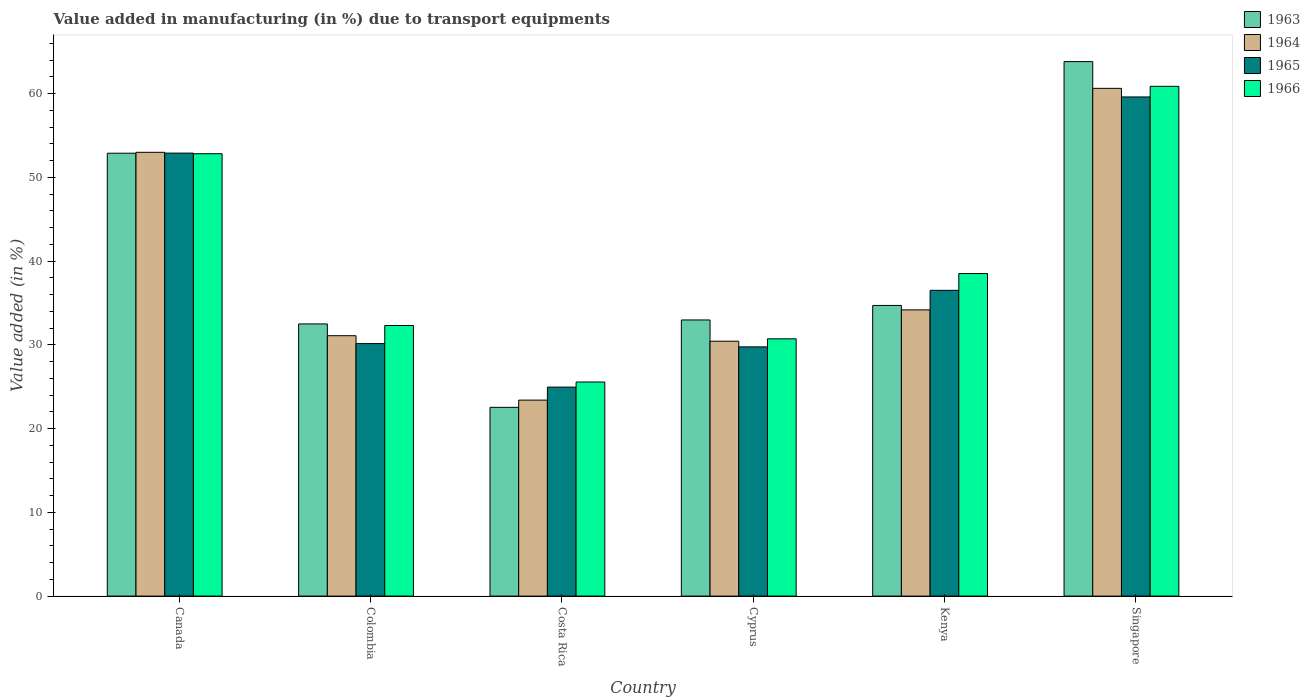How many groups of bars are there?
Offer a terse response. 6. Are the number of bars per tick equal to the number of legend labels?
Your answer should be compact. Yes. Are the number of bars on each tick of the X-axis equal?
Offer a terse response. Yes. How many bars are there on the 3rd tick from the right?
Offer a very short reply. 4. What is the label of the 3rd group of bars from the left?
Provide a short and direct response. Costa Rica. In how many cases, is the number of bars for a given country not equal to the number of legend labels?
Provide a succinct answer. 0. What is the percentage of value added in manufacturing due to transport equipments in 1965 in Singapore?
Ensure brevity in your answer.  59.59. Across all countries, what is the maximum percentage of value added in manufacturing due to transport equipments in 1963?
Offer a very short reply. 63.81. Across all countries, what is the minimum percentage of value added in manufacturing due to transport equipments in 1966?
Provide a short and direct response. 25.56. In which country was the percentage of value added in manufacturing due to transport equipments in 1966 maximum?
Make the answer very short. Singapore. What is the total percentage of value added in manufacturing due to transport equipments in 1965 in the graph?
Your response must be concise. 233.83. What is the difference between the percentage of value added in manufacturing due to transport equipments in 1964 in Colombia and that in Kenya?
Ensure brevity in your answer.  -3.08. What is the difference between the percentage of value added in manufacturing due to transport equipments in 1963 in Singapore and the percentage of value added in manufacturing due to transport equipments in 1965 in Costa Rica?
Your answer should be compact. 38.86. What is the average percentage of value added in manufacturing due to transport equipments in 1963 per country?
Your answer should be very brief. 39.9. What is the difference between the percentage of value added in manufacturing due to transport equipments of/in 1965 and percentage of value added in manufacturing due to transport equipments of/in 1964 in Canada?
Offer a terse response. -0.1. In how many countries, is the percentage of value added in manufacturing due to transport equipments in 1966 greater than 16 %?
Ensure brevity in your answer.  6. What is the ratio of the percentage of value added in manufacturing due to transport equipments in 1963 in Canada to that in Cyprus?
Provide a succinct answer. 1.6. Is the percentage of value added in manufacturing due to transport equipments in 1964 in Canada less than that in Cyprus?
Offer a very short reply. No. What is the difference between the highest and the second highest percentage of value added in manufacturing due to transport equipments in 1964?
Ensure brevity in your answer.  -26.45. What is the difference between the highest and the lowest percentage of value added in manufacturing due to transport equipments in 1966?
Your answer should be very brief. 35.3. In how many countries, is the percentage of value added in manufacturing due to transport equipments in 1964 greater than the average percentage of value added in manufacturing due to transport equipments in 1964 taken over all countries?
Ensure brevity in your answer.  2. What does the 3rd bar from the left in Colombia represents?
Give a very brief answer. 1965. What does the 2nd bar from the right in Canada represents?
Ensure brevity in your answer.  1965. Is it the case that in every country, the sum of the percentage of value added in manufacturing due to transport equipments in 1963 and percentage of value added in manufacturing due to transport equipments in 1966 is greater than the percentage of value added in manufacturing due to transport equipments in 1965?
Your answer should be compact. Yes. Are all the bars in the graph horizontal?
Make the answer very short. No. What is the difference between two consecutive major ticks on the Y-axis?
Make the answer very short. 10. Does the graph contain any zero values?
Your answer should be compact. No. Does the graph contain grids?
Make the answer very short. No. Where does the legend appear in the graph?
Offer a very short reply. Top right. What is the title of the graph?
Provide a short and direct response. Value added in manufacturing (in %) due to transport equipments. What is the label or title of the X-axis?
Provide a short and direct response. Country. What is the label or title of the Y-axis?
Your answer should be very brief. Value added (in %). What is the Value added (in %) of 1963 in Canada?
Offer a very short reply. 52.87. What is the Value added (in %) of 1964 in Canada?
Offer a terse response. 52.98. What is the Value added (in %) of 1965 in Canada?
Provide a succinct answer. 52.89. What is the Value added (in %) of 1966 in Canada?
Your answer should be very brief. 52.81. What is the Value added (in %) in 1963 in Colombia?
Make the answer very short. 32.49. What is the Value added (in %) of 1964 in Colombia?
Offer a very short reply. 31.09. What is the Value added (in %) of 1965 in Colombia?
Make the answer very short. 30.15. What is the Value added (in %) of 1966 in Colombia?
Your answer should be compact. 32.3. What is the Value added (in %) in 1963 in Costa Rica?
Keep it short and to the point. 22.53. What is the Value added (in %) in 1964 in Costa Rica?
Ensure brevity in your answer.  23.4. What is the Value added (in %) in 1965 in Costa Rica?
Keep it short and to the point. 24.95. What is the Value added (in %) of 1966 in Costa Rica?
Your answer should be very brief. 25.56. What is the Value added (in %) of 1963 in Cyprus?
Offer a terse response. 32.97. What is the Value added (in %) of 1964 in Cyprus?
Your answer should be compact. 30.43. What is the Value added (in %) in 1965 in Cyprus?
Make the answer very short. 29.75. What is the Value added (in %) of 1966 in Cyprus?
Offer a very short reply. 30.72. What is the Value added (in %) in 1963 in Kenya?
Provide a short and direct response. 34.7. What is the Value added (in %) in 1964 in Kenya?
Your answer should be compact. 34.17. What is the Value added (in %) of 1965 in Kenya?
Give a very brief answer. 36.5. What is the Value added (in %) of 1966 in Kenya?
Offer a very short reply. 38.51. What is the Value added (in %) of 1963 in Singapore?
Keep it short and to the point. 63.81. What is the Value added (in %) of 1964 in Singapore?
Your response must be concise. 60.62. What is the Value added (in %) in 1965 in Singapore?
Your answer should be very brief. 59.59. What is the Value added (in %) in 1966 in Singapore?
Keep it short and to the point. 60.86. Across all countries, what is the maximum Value added (in %) of 1963?
Keep it short and to the point. 63.81. Across all countries, what is the maximum Value added (in %) of 1964?
Provide a short and direct response. 60.62. Across all countries, what is the maximum Value added (in %) of 1965?
Make the answer very short. 59.59. Across all countries, what is the maximum Value added (in %) of 1966?
Give a very brief answer. 60.86. Across all countries, what is the minimum Value added (in %) of 1963?
Make the answer very short. 22.53. Across all countries, what is the minimum Value added (in %) in 1964?
Provide a succinct answer. 23.4. Across all countries, what is the minimum Value added (in %) in 1965?
Your answer should be very brief. 24.95. Across all countries, what is the minimum Value added (in %) in 1966?
Provide a succinct answer. 25.56. What is the total Value added (in %) of 1963 in the graph?
Give a very brief answer. 239.38. What is the total Value added (in %) in 1964 in the graph?
Provide a short and direct response. 232.68. What is the total Value added (in %) of 1965 in the graph?
Provide a succinct answer. 233.83. What is the total Value added (in %) of 1966 in the graph?
Ensure brevity in your answer.  240.76. What is the difference between the Value added (in %) of 1963 in Canada and that in Colombia?
Your answer should be compact. 20.38. What is the difference between the Value added (in %) of 1964 in Canada and that in Colombia?
Make the answer very short. 21.9. What is the difference between the Value added (in %) of 1965 in Canada and that in Colombia?
Keep it short and to the point. 22.74. What is the difference between the Value added (in %) of 1966 in Canada and that in Colombia?
Keep it short and to the point. 20.51. What is the difference between the Value added (in %) in 1963 in Canada and that in Costa Rica?
Provide a short and direct response. 30.34. What is the difference between the Value added (in %) in 1964 in Canada and that in Costa Rica?
Ensure brevity in your answer.  29.59. What is the difference between the Value added (in %) of 1965 in Canada and that in Costa Rica?
Give a very brief answer. 27.93. What is the difference between the Value added (in %) of 1966 in Canada and that in Costa Rica?
Provide a succinct answer. 27.25. What is the difference between the Value added (in %) in 1963 in Canada and that in Cyprus?
Provide a succinct answer. 19.91. What is the difference between the Value added (in %) in 1964 in Canada and that in Cyprus?
Offer a terse response. 22.55. What is the difference between the Value added (in %) of 1965 in Canada and that in Cyprus?
Your answer should be very brief. 23.13. What is the difference between the Value added (in %) in 1966 in Canada and that in Cyprus?
Offer a very short reply. 22.1. What is the difference between the Value added (in %) in 1963 in Canada and that in Kenya?
Your answer should be very brief. 18.17. What is the difference between the Value added (in %) in 1964 in Canada and that in Kenya?
Offer a very short reply. 18.81. What is the difference between the Value added (in %) of 1965 in Canada and that in Kenya?
Ensure brevity in your answer.  16.38. What is the difference between the Value added (in %) in 1966 in Canada and that in Kenya?
Your response must be concise. 14.3. What is the difference between the Value added (in %) in 1963 in Canada and that in Singapore?
Your response must be concise. -10.94. What is the difference between the Value added (in %) in 1964 in Canada and that in Singapore?
Offer a terse response. -7.63. What is the difference between the Value added (in %) of 1965 in Canada and that in Singapore?
Provide a succinct answer. -6.71. What is the difference between the Value added (in %) of 1966 in Canada and that in Singapore?
Your answer should be compact. -8.05. What is the difference between the Value added (in %) in 1963 in Colombia and that in Costa Rica?
Your answer should be very brief. 9.96. What is the difference between the Value added (in %) of 1964 in Colombia and that in Costa Rica?
Provide a short and direct response. 7.69. What is the difference between the Value added (in %) of 1965 in Colombia and that in Costa Rica?
Keep it short and to the point. 5.2. What is the difference between the Value added (in %) in 1966 in Colombia and that in Costa Rica?
Ensure brevity in your answer.  6.74. What is the difference between the Value added (in %) in 1963 in Colombia and that in Cyprus?
Provide a succinct answer. -0.47. What is the difference between the Value added (in %) of 1964 in Colombia and that in Cyprus?
Ensure brevity in your answer.  0.66. What is the difference between the Value added (in %) of 1965 in Colombia and that in Cyprus?
Your answer should be very brief. 0.39. What is the difference between the Value added (in %) in 1966 in Colombia and that in Cyprus?
Your response must be concise. 1.59. What is the difference between the Value added (in %) in 1963 in Colombia and that in Kenya?
Provide a short and direct response. -2.21. What is the difference between the Value added (in %) in 1964 in Colombia and that in Kenya?
Your answer should be very brief. -3.08. What is the difference between the Value added (in %) of 1965 in Colombia and that in Kenya?
Your answer should be very brief. -6.36. What is the difference between the Value added (in %) of 1966 in Colombia and that in Kenya?
Give a very brief answer. -6.2. What is the difference between the Value added (in %) in 1963 in Colombia and that in Singapore?
Ensure brevity in your answer.  -31.32. What is the difference between the Value added (in %) of 1964 in Colombia and that in Singapore?
Make the answer very short. -29.53. What is the difference between the Value added (in %) in 1965 in Colombia and that in Singapore?
Ensure brevity in your answer.  -29.45. What is the difference between the Value added (in %) of 1966 in Colombia and that in Singapore?
Offer a terse response. -28.56. What is the difference between the Value added (in %) of 1963 in Costa Rica and that in Cyprus?
Your response must be concise. -10.43. What is the difference between the Value added (in %) of 1964 in Costa Rica and that in Cyprus?
Keep it short and to the point. -7.03. What is the difference between the Value added (in %) of 1965 in Costa Rica and that in Cyprus?
Your answer should be compact. -4.8. What is the difference between the Value added (in %) of 1966 in Costa Rica and that in Cyprus?
Your answer should be very brief. -5.16. What is the difference between the Value added (in %) in 1963 in Costa Rica and that in Kenya?
Your response must be concise. -12.17. What is the difference between the Value added (in %) of 1964 in Costa Rica and that in Kenya?
Keep it short and to the point. -10.77. What is the difference between the Value added (in %) of 1965 in Costa Rica and that in Kenya?
Your answer should be very brief. -11.55. What is the difference between the Value added (in %) in 1966 in Costa Rica and that in Kenya?
Offer a terse response. -12.95. What is the difference between the Value added (in %) of 1963 in Costa Rica and that in Singapore?
Make the answer very short. -41.28. What is the difference between the Value added (in %) of 1964 in Costa Rica and that in Singapore?
Your answer should be compact. -37.22. What is the difference between the Value added (in %) of 1965 in Costa Rica and that in Singapore?
Give a very brief answer. -34.64. What is the difference between the Value added (in %) of 1966 in Costa Rica and that in Singapore?
Your answer should be compact. -35.3. What is the difference between the Value added (in %) of 1963 in Cyprus and that in Kenya?
Make the answer very short. -1.73. What is the difference between the Value added (in %) in 1964 in Cyprus and that in Kenya?
Give a very brief answer. -3.74. What is the difference between the Value added (in %) in 1965 in Cyprus and that in Kenya?
Provide a succinct answer. -6.75. What is the difference between the Value added (in %) in 1966 in Cyprus and that in Kenya?
Offer a very short reply. -7.79. What is the difference between the Value added (in %) in 1963 in Cyprus and that in Singapore?
Your response must be concise. -30.84. What is the difference between the Value added (in %) in 1964 in Cyprus and that in Singapore?
Offer a terse response. -30.19. What is the difference between the Value added (in %) in 1965 in Cyprus and that in Singapore?
Your answer should be very brief. -29.84. What is the difference between the Value added (in %) of 1966 in Cyprus and that in Singapore?
Your response must be concise. -30.14. What is the difference between the Value added (in %) in 1963 in Kenya and that in Singapore?
Provide a short and direct response. -29.11. What is the difference between the Value added (in %) in 1964 in Kenya and that in Singapore?
Your answer should be very brief. -26.45. What is the difference between the Value added (in %) in 1965 in Kenya and that in Singapore?
Keep it short and to the point. -23.09. What is the difference between the Value added (in %) in 1966 in Kenya and that in Singapore?
Give a very brief answer. -22.35. What is the difference between the Value added (in %) in 1963 in Canada and the Value added (in %) in 1964 in Colombia?
Offer a terse response. 21.79. What is the difference between the Value added (in %) in 1963 in Canada and the Value added (in %) in 1965 in Colombia?
Offer a very short reply. 22.73. What is the difference between the Value added (in %) of 1963 in Canada and the Value added (in %) of 1966 in Colombia?
Provide a succinct answer. 20.57. What is the difference between the Value added (in %) in 1964 in Canada and the Value added (in %) in 1965 in Colombia?
Ensure brevity in your answer.  22.84. What is the difference between the Value added (in %) of 1964 in Canada and the Value added (in %) of 1966 in Colombia?
Provide a short and direct response. 20.68. What is the difference between the Value added (in %) in 1965 in Canada and the Value added (in %) in 1966 in Colombia?
Ensure brevity in your answer.  20.58. What is the difference between the Value added (in %) of 1963 in Canada and the Value added (in %) of 1964 in Costa Rica?
Your response must be concise. 29.48. What is the difference between the Value added (in %) of 1963 in Canada and the Value added (in %) of 1965 in Costa Rica?
Your response must be concise. 27.92. What is the difference between the Value added (in %) in 1963 in Canada and the Value added (in %) in 1966 in Costa Rica?
Your answer should be compact. 27.31. What is the difference between the Value added (in %) of 1964 in Canada and the Value added (in %) of 1965 in Costa Rica?
Give a very brief answer. 28.03. What is the difference between the Value added (in %) in 1964 in Canada and the Value added (in %) in 1966 in Costa Rica?
Provide a succinct answer. 27.42. What is the difference between the Value added (in %) in 1965 in Canada and the Value added (in %) in 1966 in Costa Rica?
Make the answer very short. 27.33. What is the difference between the Value added (in %) in 1963 in Canada and the Value added (in %) in 1964 in Cyprus?
Offer a terse response. 22.44. What is the difference between the Value added (in %) in 1963 in Canada and the Value added (in %) in 1965 in Cyprus?
Offer a very short reply. 23.12. What is the difference between the Value added (in %) in 1963 in Canada and the Value added (in %) in 1966 in Cyprus?
Your answer should be very brief. 22.16. What is the difference between the Value added (in %) in 1964 in Canada and the Value added (in %) in 1965 in Cyprus?
Offer a terse response. 23.23. What is the difference between the Value added (in %) in 1964 in Canada and the Value added (in %) in 1966 in Cyprus?
Your answer should be compact. 22.27. What is the difference between the Value added (in %) of 1965 in Canada and the Value added (in %) of 1966 in Cyprus?
Offer a terse response. 22.17. What is the difference between the Value added (in %) of 1963 in Canada and the Value added (in %) of 1964 in Kenya?
Make the answer very short. 18.7. What is the difference between the Value added (in %) of 1963 in Canada and the Value added (in %) of 1965 in Kenya?
Keep it short and to the point. 16.37. What is the difference between the Value added (in %) of 1963 in Canada and the Value added (in %) of 1966 in Kenya?
Provide a short and direct response. 14.37. What is the difference between the Value added (in %) in 1964 in Canada and the Value added (in %) in 1965 in Kenya?
Provide a succinct answer. 16.48. What is the difference between the Value added (in %) of 1964 in Canada and the Value added (in %) of 1966 in Kenya?
Offer a very short reply. 14.47. What is the difference between the Value added (in %) in 1965 in Canada and the Value added (in %) in 1966 in Kenya?
Your answer should be compact. 14.38. What is the difference between the Value added (in %) in 1963 in Canada and the Value added (in %) in 1964 in Singapore?
Keep it short and to the point. -7.74. What is the difference between the Value added (in %) of 1963 in Canada and the Value added (in %) of 1965 in Singapore?
Provide a succinct answer. -6.72. What is the difference between the Value added (in %) of 1963 in Canada and the Value added (in %) of 1966 in Singapore?
Keep it short and to the point. -7.99. What is the difference between the Value added (in %) of 1964 in Canada and the Value added (in %) of 1965 in Singapore?
Your answer should be very brief. -6.61. What is the difference between the Value added (in %) of 1964 in Canada and the Value added (in %) of 1966 in Singapore?
Keep it short and to the point. -7.88. What is the difference between the Value added (in %) of 1965 in Canada and the Value added (in %) of 1966 in Singapore?
Your answer should be compact. -7.97. What is the difference between the Value added (in %) of 1963 in Colombia and the Value added (in %) of 1964 in Costa Rica?
Provide a short and direct response. 9.1. What is the difference between the Value added (in %) of 1963 in Colombia and the Value added (in %) of 1965 in Costa Rica?
Ensure brevity in your answer.  7.54. What is the difference between the Value added (in %) in 1963 in Colombia and the Value added (in %) in 1966 in Costa Rica?
Your answer should be very brief. 6.93. What is the difference between the Value added (in %) of 1964 in Colombia and the Value added (in %) of 1965 in Costa Rica?
Your answer should be very brief. 6.14. What is the difference between the Value added (in %) of 1964 in Colombia and the Value added (in %) of 1966 in Costa Rica?
Your response must be concise. 5.53. What is the difference between the Value added (in %) in 1965 in Colombia and the Value added (in %) in 1966 in Costa Rica?
Provide a succinct answer. 4.59. What is the difference between the Value added (in %) of 1963 in Colombia and the Value added (in %) of 1964 in Cyprus?
Your answer should be compact. 2.06. What is the difference between the Value added (in %) of 1963 in Colombia and the Value added (in %) of 1965 in Cyprus?
Ensure brevity in your answer.  2.74. What is the difference between the Value added (in %) of 1963 in Colombia and the Value added (in %) of 1966 in Cyprus?
Provide a short and direct response. 1.78. What is the difference between the Value added (in %) in 1964 in Colombia and the Value added (in %) in 1965 in Cyprus?
Ensure brevity in your answer.  1.33. What is the difference between the Value added (in %) in 1964 in Colombia and the Value added (in %) in 1966 in Cyprus?
Ensure brevity in your answer.  0.37. What is the difference between the Value added (in %) in 1965 in Colombia and the Value added (in %) in 1966 in Cyprus?
Provide a succinct answer. -0.57. What is the difference between the Value added (in %) in 1963 in Colombia and the Value added (in %) in 1964 in Kenya?
Your answer should be very brief. -1.68. What is the difference between the Value added (in %) of 1963 in Colombia and the Value added (in %) of 1965 in Kenya?
Make the answer very short. -4.01. What is the difference between the Value added (in %) of 1963 in Colombia and the Value added (in %) of 1966 in Kenya?
Provide a succinct answer. -6.01. What is the difference between the Value added (in %) in 1964 in Colombia and the Value added (in %) in 1965 in Kenya?
Your response must be concise. -5.42. What is the difference between the Value added (in %) of 1964 in Colombia and the Value added (in %) of 1966 in Kenya?
Your response must be concise. -7.42. What is the difference between the Value added (in %) of 1965 in Colombia and the Value added (in %) of 1966 in Kenya?
Ensure brevity in your answer.  -8.36. What is the difference between the Value added (in %) in 1963 in Colombia and the Value added (in %) in 1964 in Singapore?
Ensure brevity in your answer.  -28.12. What is the difference between the Value added (in %) of 1963 in Colombia and the Value added (in %) of 1965 in Singapore?
Your answer should be very brief. -27.1. What is the difference between the Value added (in %) of 1963 in Colombia and the Value added (in %) of 1966 in Singapore?
Your answer should be very brief. -28.37. What is the difference between the Value added (in %) in 1964 in Colombia and the Value added (in %) in 1965 in Singapore?
Your response must be concise. -28.51. What is the difference between the Value added (in %) in 1964 in Colombia and the Value added (in %) in 1966 in Singapore?
Provide a short and direct response. -29.77. What is the difference between the Value added (in %) in 1965 in Colombia and the Value added (in %) in 1966 in Singapore?
Make the answer very short. -30.71. What is the difference between the Value added (in %) of 1963 in Costa Rica and the Value added (in %) of 1964 in Cyprus?
Ensure brevity in your answer.  -7.9. What is the difference between the Value added (in %) of 1963 in Costa Rica and the Value added (in %) of 1965 in Cyprus?
Make the answer very short. -7.22. What is the difference between the Value added (in %) of 1963 in Costa Rica and the Value added (in %) of 1966 in Cyprus?
Make the answer very short. -8.18. What is the difference between the Value added (in %) in 1964 in Costa Rica and the Value added (in %) in 1965 in Cyprus?
Provide a succinct answer. -6.36. What is the difference between the Value added (in %) in 1964 in Costa Rica and the Value added (in %) in 1966 in Cyprus?
Your answer should be very brief. -7.32. What is the difference between the Value added (in %) in 1965 in Costa Rica and the Value added (in %) in 1966 in Cyprus?
Make the answer very short. -5.77. What is the difference between the Value added (in %) in 1963 in Costa Rica and the Value added (in %) in 1964 in Kenya?
Your response must be concise. -11.64. What is the difference between the Value added (in %) in 1963 in Costa Rica and the Value added (in %) in 1965 in Kenya?
Ensure brevity in your answer.  -13.97. What is the difference between the Value added (in %) in 1963 in Costa Rica and the Value added (in %) in 1966 in Kenya?
Offer a very short reply. -15.97. What is the difference between the Value added (in %) of 1964 in Costa Rica and the Value added (in %) of 1965 in Kenya?
Make the answer very short. -13.11. What is the difference between the Value added (in %) of 1964 in Costa Rica and the Value added (in %) of 1966 in Kenya?
Your answer should be very brief. -15.11. What is the difference between the Value added (in %) in 1965 in Costa Rica and the Value added (in %) in 1966 in Kenya?
Your answer should be compact. -13.56. What is the difference between the Value added (in %) of 1963 in Costa Rica and the Value added (in %) of 1964 in Singapore?
Keep it short and to the point. -38.08. What is the difference between the Value added (in %) in 1963 in Costa Rica and the Value added (in %) in 1965 in Singapore?
Keep it short and to the point. -37.06. What is the difference between the Value added (in %) in 1963 in Costa Rica and the Value added (in %) in 1966 in Singapore?
Offer a very short reply. -38.33. What is the difference between the Value added (in %) of 1964 in Costa Rica and the Value added (in %) of 1965 in Singapore?
Provide a succinct answer. -36.19. What is the difference between the Value added (in %) of 1964 in Costa Rica and the Value added (in %) of 1966 in Singapore?
Offer a terse response. -37.46. What is the difference between the Value added (in %) of 1965 in Costa Rica and the Value added (in %) of 1966 in Singapore?
Offer a very short reply. -35.91. What is the difference between the Value added (in %) of 1963 in Cyprus and the Value added (in %) of 1964 in Kenya?
Provide a short and direct response. -1.2. What is the difference between the Value added (in %) of 1963 in Cyprus and the Value added (in %) of 1965 in Kenya?
Your answer should be compact. -3.54. What is the difference between the Value added (in %) in 1963 in Cyprus and the Value added (in %) in 1966 in Kenya?
Provide a short and direct response. -5.54. What is the difference between the Value added (in %) in 1964 in Cyprus and the Value added (in %) in 1965 in Kenya?
Your response must be concise. -6.07. What is the difference between the Value added (in %) in 1964 in Cyprus and the Value added (in %) in 1966 in Kenya?
Provide a short and direct response. -8.08. What is the difference between the Value added (in %) in 1965 in Cyprus and the Value added (in %) in 1966 in Kenya?
Keep it short and to the point. -8.75. What is the difference between the Value added (in %) of 1963 in Cyprus and the Value added (in %) of 1964 in Singapore?
Provide a short and direct response. -27.65. What is the difference between the Value added (in %) in 1963 in Cyprus and the Value added (in %) in 1965 in Singapore?
Your answer should be compact. -26.62. What is the difference between the Value added (in %) in 1963 in Cyprus and the Value added (in %) in 1966 in Singapore?
Provide a succinct answer. -27.89. What is the difference between the Value added (in %) in 1964 in Cyprus and the Value added (in %) in 1965 in Singapore?
Provide a succinct answer. -29.16. What is the difference between the Value added (in %) of 1964 in Cyprus and the Value added (in %) of 1966 in Singapore?
Make the answer very short. -30.43. What is the difference between the Value added (in %) of 1965 in Cyprus and the Value added (in %) of 1966 in Singapore?
Your response must be concise. -31.11. What is the difference between the Value added (in %) in 1963 in Kenya and the Value added (in %) in 1964 in Singapore?
Offer a terse response. -25.92. What is the difference between the Value added (in %) of 1963 in Kenya and the Value added (in %) of 1965 in Singapore?
Provide a short and direct response. -24.89. What is the difference between the Value added (in %) of 1963 in Kenya and the Value added (in %) of 1966 in Singapore?
Ensure brevity in your answer.  -26.16. What is the difference between the Value added (in %) of 1964 in Kenya and the Value added (in %) of 1965 in Singapore?
Keep it short and to the point. -25.42. What is the difference between the Value added (in %) in 1964 in Kenya and the Value added (in %) in 1966 in Singapore?
Your answer should be compact. -26.69. What is the difference between the Value added (in %) of 1965 in Kenya and the Value added (in %) of 1966 in Singapore?
Your answer should be very brief. -24.36. What is the average Value added (in %) of 1963 per country?
Your answer should be very brief. 39.9. What is the average Value added (in %) in 1964 per country?
Make the answer very short. 38.78. What is the average Value added (in %) in 1965 per country?
Offer a very short reply. 38.97. What is the average Value added (in %) in 1966 per country?
Provide a succinct answer. 40.13. What is the difference between the Value added (in %) of 1963 and Value added (in %) of 1964 in Canada?
Ensure brevity in your answer.  -0.11. What is the difference between the Value added (in %) of 1963 and Value added (in %) of 1965 in Canada?
Ensure brevity in your answer.  -0.01. What is the difference between the Value added (in %) in 1963 and Value added (in %) in 1966 in Canada?
Your answer should be very brief. 0.06. What is the difference between the Value added (in %) in 1964 and Value added (in %) in 1965 in Canada?
Keep it short and to the point. 0.1. What is the difference between the Value added (in %) of 1964 and Value added (in %) of 1966 in Canada?
Your response must be concise. 0.17. What is the difference between the Value added (in %) of 1965 and Value added (in %) of 1966 in Canada?
Offer a very short reply. 0.07. What is the difference between the Value added (in %) in 1963 and Value added (in %) in 1964 in Colombia?
Keep it short and to the point. 1.41. What is the difference between the Value added (in %) in 1963 and Value added (in %) in 1965 in Colombia?
Provide a short and direct response. 2.35. What is the difference between the Value added (in %) of 1963 and Value added (in %) of 1966 in Colombia?
Offer a very short reply. 0.19. What is the difference between the Value added (in %) in 1964 and Value added (in %) in 1965 in Colombia?
Give a very brief answer. 0.94. What is the difference between the Value added (in %) of 1964 and Value added (in %) of 1966 in Colombia?
Make the answer very short. -1.22. What is the difference between the Value added (in %) of 1965 and Value added (in %) of 1966 in Colombia?
Offer a very short reply. -2.16. What is the difference between the Value added (in %) in 1963 and Value added (in %) in 1964 in Costa Rica?
Offer a terse response. -0.86. What is the difference between the Value added (in %) in 1963 and Value added (in %) in 1965 in Costa Rica?
Your answer should be very brief. -2.42. What is the difference between the Value added (in %) of 1963 and Value added (in %) of 1966 in Costa Rica?
Give a very brief answer. -3.03. What is the difference between the Value added (in %) of 1964 and Value added (in %) of 1965 in Costa Rica?
Provide a succinct answer. -1.55. What is the difference between the Value added (in %) of 1964 and Value added (in %) of 1966 in Costa Rica?
Offer a very short reply. -2.16. What is the difference between the Value added (in %) of 1965 and Value added (in %) of 1966 in Costa Rica?
Offer a terse response. -0.61. What is the difference between the Value added (in %) in 1963 and Value added (in %) in 1964 in Cyprus?
Your answer should be compact. 2.54. What is the difference between the Value added (in %) in 1963 and Value added (in %) in 1965 in Cyprus?
Make the answer very short. 3.21. What is the difference between the Value added (in %) of 1963 and Value added (in %) of 1966 in Cyprus?
Your answer should be compact. 2.25. What is the difference between the Value added (in %) of 1964 and Value added (in %) of 1965 in Cyprus?
Make the answer very short. 0.68. What is the difference between the Value added (in %) in 1964 and Value added (in %) in 1966 in Cyprus?
Provide a short and direct response. -0.29. What is the difference between the Value added (in %) of 1965 and Value added (in %) of 1966 in Cyprus?
Your answer should be very brief. -0.96. What is the difference between the Value added (in %) of 1963 and Value added (in %) of 1964 in Kenya?
Provide a short and direct response. 0.53. What is the difference between the Value added (in %) in 1963 and Value added (in %) in 1965 in Kenya?
Ensure brevity in your answer.  -1.8. What is the difference between the Value added (in %) in 1963 and Value added (in %) in 1966 in Kenya?
Your response must be concise. -3.81. What is the difference between the Value added (in %) in 1964 and Value added (in %) in 1965 in Kenya?
Your response must be concise. -2.33. What is the difference between the Value added (in %) of 1964 and Value added (in %) of 1966 in Kenya?
Make the answer very short. -4.34. What is the difference between the Value added (in %) of 1965 and Value added (in %) of 1966 in Kenya?
Give a very brief answer. -2. What is the difference between the Value added (in %) of 1963 and Value added (in %) of 1964 in Singapore?
Keep it short and to the point. 3.19. What is the difference between the Value added (in %) of 1963 and Value added (in %) of 1965 in Singapore?
Provide a succinct answer. 4.22. What is the difference between the Value added (in %) of 1963 and Value added (in %) of 1966 in Singapore?
Make the answer very short. 2.95. What is the difference between the Value added (in %) of 1964 and Value added (in %) of 1965 in Singapore?
Keep it short and to the point. 1.03. What is the difference between the Value added (in %) in 1964 and Value added (in %) in 1966 in Singapore?
Your answer should be very brief. -0.24. What is the difference between the Value added (in %) in 1965 and Value added (in %) in 1966 in Singapore?
Your answer should be very brief. -1.27. What is the ratio of the Value added (in %) of 1963 in Canada to that in Colombia?
Make the answer very short. 1.63. What is the ratio of the Value added (in %) in 1964 in Canada to that in Colombia?
Your answer should be very brief. 1.7. What is the ratio of the Value added (in %) of 1965 in Canada to that in Colombia?
Your answer should be compact. 1.75. What is the ratio of the Value added (in %) in 1966 in Canada to that in Colombia?
Offer a very short reply. 1.63. What is the ratio of the Value added (in %) in 1963 in Canada to that in Costa Rica?
Make the answer very short. 2.35. What is the ratio of the Value added (in %) in 1964 in Canada to that in Costa Rica?
Provide a short and direct response. 2.26. What is the ratio of the Value added (in %) of 1965 in Canada to that in Costa Rica?
Make the answer very short. 2.12. What is the ratio of the Value added (in %) in 1966 in Canada to that in Costa Rica?
Your answer should be very brief. 2.07. What is the ratio of the Value added (in %) in 1963 in Canada to that in Cyprus?
Offer a very short reply. 1.6. What is the ratio of the Value added (in %) in 1964 in Canada to that in Cyprus?
Your answer should be very brief. 1.74. What is the ratio of the Value added (in %) of 1965 in Canada to that in Cyprus?
Give a very brief answer. 1.78. What is the ratio of the Value added (in %) of 1966 in Canada to that in Cyprus?
Provide a short and direct response. 1.72. What is the ratio of the Value added (in %) in 1963 in Canada to that in Kenya?
Give a very brief answer. 1.52. What is the ratio of the Value added (in %) of 1964 in Canada to that in Kenya?
Offer a very short reply. 1.55. What is the ratio of the Value added (in %) of 1965 in Canada to that in Kenya?
Make the answer very short. 1.45. What is the ratio of the Value added (in %) of 1966 in Canada to that in Kenya?
Provide a succinct answer. 1.37. What is the ratio of the Value added (in %) in 1963 in Canada to that in Singapore?
Ensure brevity in your answer.  0.83. What is the ratio of the Value added (in %) in 1964 in Canada to that in Singapore?
Provide a succinct answer. 0.87. What is the ratio of the Value added (in %) in 1965 in Canada to that in Singapore?
Your answer should be very brief. 0.89. What is the ratio of the Value added (in %) of 1966 in Canada to that in Singapore?
Provide a short and direct response. 0.87. What is the ratio of the Value added (in %) in 1963 in Colombia to that in Costa Rica?
Make the answer very short. 1.44. What is the ratio of the Value added (in %) in 1964 in Colombia to that in Costa Rica?
Your answer should be very brief. 1.33. What is the ratio of the Value added (in %) in 1965 in Colombia to that in Costa Rica?
Your response must be concise. 1.21. What is the ratio of the Value added (in %) in 1966 in Colombia to that in Costa Rica?
Your answer should be very brief. 1.26. What is the ratio of the Value added (in %) of 1963 in Colombia to that in Cyprus?
Provide a succinct answer. 0.99. What is the ratio of the Value added (in %) of 1964 in Colombia to that in Cyprus?
Give a very brief answer. 1.02. What is the ratio of the Value added (in %) of 1965 in Colombia to that in Cyprus?
Provide a short and direct response. 1.01. What is the ratio of the Value added (in %) of 1966 in Colombia to that in Cyprus?
Your response must be concise. 1.05. What is the ratio of the Value added (in %) of 1963 in Colombia to that in Kenya?
Your response must be concise. 0.94. What is the ratio of the Value added (in %) of 1964 in Colombia to that in Kenya?
Your answer should be compact. 0.91. What is the ratio of the Value added (in %) of 1965 in Colombia to that in Kenya?
Your answer should be compact. 0.83. What is the ratio of the Value added (in %) of 1966 in Colombia to that in Kenya?
Give a very brief answer. 0.84. What is the ratio of the Value added (in %) in 1963 in Colombia to that in Singapore?
Your response must be concise. 0.51. What is the ratio of the Value added (in %) in 1964 in Colombia to that in Singapore?
Keep it short and to the point. 0.51. What is the ratio of the Value added (in %) in 1965 in Colombia to that in Singapore?
Offer a terse response. 0.51. What is the ratio of the Value added (in %) of 1966 in Colombia to that in Singapore?
Ensure brevity in your answer.  0.53. What is the ratio of the Value added (in %) of 1963 in Costa Rica to that in Cyprus?
Provide a succinct answer. 0.68. What is the ratio of the Value added (in %) in 1964 in Costa Rica to that in Cyprus?
Keep it short and to the point. 0.77. What is the ratio of the Value added (in %) of 1965 in Costa Rica to that in Cyprus?
Keep it short and to the point. 0.84. What is the ratio of the Value added (in %) of 1966 in Costa Rica to that in Cyprus?
Your answer should be very brief. 0.83. What is the ratio of the Value added (in %) of 1963 in Costa Rica to that in Kenya?
Give a very brief answer. 0.65. What is the ratio of the Value added (in %) of 1964 in Costa Rica to that in Kenya?
Offer a very short reply. 0.68. What is the ratio of the Value added (in %) of 1965 in Costa Rica to that in Kenya?
Offer a terse response. 0.68. What is the ratio of the Value added (in %) in 1966 in Costa Rica to that in Kenya?
Provide a short and direct response. 0.66. What is the ratio of the Value added (in %) of 1963 in Costa Rica to that in Singapore?
Give a very brief answer. 0.35. What is the ratio of the Value added (in %) in 1964 in Costa Rica to that in Singapore?
Offer a terse response. 0.39. What is the ratio of the Value added (in %) in 1965 in Costa Rica to that in Singapore?
Make the answer very short. 0.42. What is the ratio of the Value added (in %) of 1966 in Costa Rica to that in Singapore?
Provide a short and direct response. 0.42. What is the ratio of the Value added (in %) of 1963 in Cyprus to that in Kenya?
Your answer should be compact. 0.95. What is the ratio of the Value added (in %) in 1964 in Cyprus to that in Kenya?
Offer a terse response. 0.89. What is the ratio of the Value added (in %) in 1965 in Cyprus to that in Kenya?
Your answer should be compact. 0.82. What is the ratio of the Value added (in %) in 1966 in Cyprus to that in Kenya?
Give a very brief answer. 0.8. What is the ratio of the Value added (in %) of 1963 in Cyprus to that in Singapore?
Your response must be concise. 0.52. What is the ratio of the Value added (in %) in 1964 in Cyprus to that in Singapore?
Give a very brief answer. 0.5. What is the ratio of the Value added (in %) in 1965 in Cyprus to that in Singapore?
Make the answer very short. 0.5. What is the ratio of the Value added (in %) of 1966 in Cyprus to that in Singapore?
Your answer should be very brief. 0.5. What is the ratio of the Value added (in %) of 1963 in Kenya to that in Singapore?
Your response must be concise. 0.54. What is the ratio of the Value added (in %) of 1964 in Kenya to that in Singapore?
Keep it short and to the point. 0.56. What is the ratio of the Value added (in %) in 1965 in Kenya to that in Singapore?
Offer a very short reply. 0.61. What is the ratio of the Value added (in %) of 1966 in Kenya to that in Singapore?
Offer a very short reply. 0.63. What is the difference between the highest and the second highest Value added (in %) in 1963?
Keep it short and to the point. 10.94. What is the difference between the highest and the second highest Value added (in %) of 1964?
Your answer should be very brief. 7.63. What is the difference between the highest and the second highest Value added (in %) in 1965?
Give a very brief answer. 6.71. What is the difference between the highest and the second highest Value added (in %) of 1966?
Provide a short and direct response. 8.05. What is the difference between the highest and the lowest Value added (in %) in 1963?
Ensure brevity in your answer.  41.28. What is the difference between the highest and the lowest Value added (in %) in 1964?
Keep it short and to the point. 37.22. What is the difference between the highest and the lowest Value added (in %) in 1965?
Keep it short and to the point. 34.64. What is the difference between the highest and the lowest Value added (in %) of 1966?
Provide a succinct answer. 35.3. 